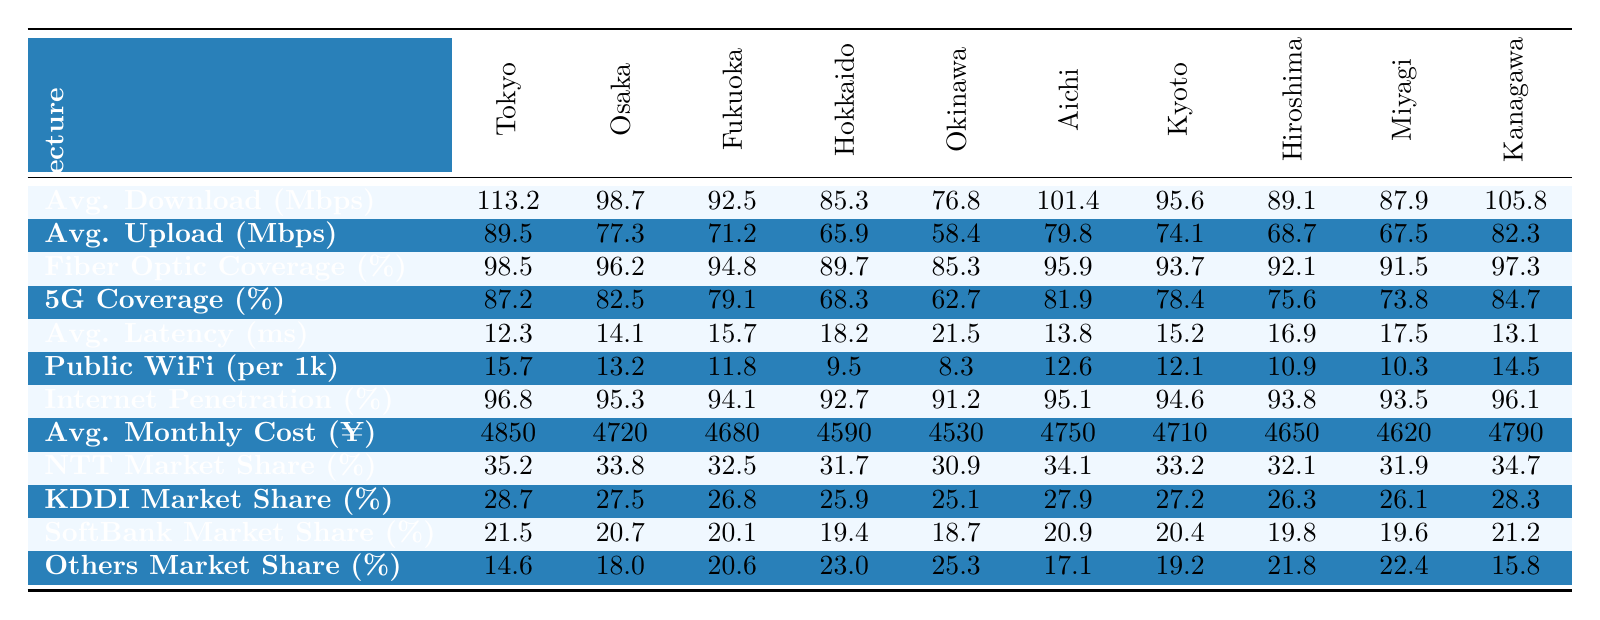What is the average download speed in Tokyo? The average download speed for Tokyo is listed in the table under the "Avg. Download (Mbps)" row, which shows a value of 113.2 Mbps.
Answer: 113.2 Mbps Which prefecture has the lowest average upload speed? By examining the "Avg. Upload (Mbps)" row, we can see that Okinawa has the lowest value of 58.4 Mbps.
Answer: Okinawa What is the fiber optic coverage percentage in Hokkaido? The table indicates that the fiber optic coverage for Hokkaido is 89.7%, found in the "Fiber Optic Coverage (%)" row.
Answer: 89.7% Calculate the difference in average download speed between Tokyo and Fukuoka. The average download speed in Tokyo is 113.2 Mbps and in Fukuoka it is 92.5 Mbps. To find the difference, we subtract 92.5 from 113.2, which gives us 20.7 Mbps.
Answer: 20.7 Mbps Does Osaka have a higher average latency than Miyagi? The average latency for Osaka is 14.1 ms, while for Miyagi it is 17.5 ms. Since 14.1 is less than 17.5, Osaka does not have a higher average latency.
Answer: No What percentage of the market is shared by the 'Others' category in Kanagawa? According to the table, the market share percentage for the 'Others' category in Kanagawa is 15.8%, which is explicitly stated under the "Others Market Share (%)" row.
Answer: 15.8% What is the average monthly internet cost across the given prefectures? To find the average monthly internet cost, we add the values from the "Avg. Monthly Cost (¥)" row and divide by 10 (the number of prefectures). The total is (4850 + 4720 + 4680 + 4590 + 4530 + 4750 + 4710 + 4650 + 4620 + 4790) = 47070. Dividing by 10 gives us an average cost of 4707 yen.
Answer: 4707 yen Which prefecture has the highest internet penetration rate percentage? The table shows that Tokyo has an internet penetration rate of 96.8%, which is the highest among all prefectures listed.
Answer: Tokyo Is the fiber optic coverage percentage in Aichi above 90%? The fiber optic coverage percentage for Aichi is listed as 95.9%, which is above 90%.
Answer: Yes What is the average market share of KDDI across all listed prefectures? To find the average market share of KDDI, we'll sum its market shares across the prefectures (28.7 + 27.5 + 26.8 + 25.9 + 25.1 + 27.9 + 27.2 + 26.3 + 26.1 + 28.3 =  260.8) and divide by 10. The average is 260.8 / 10 = 26.08%.
Answer: 26.08% 